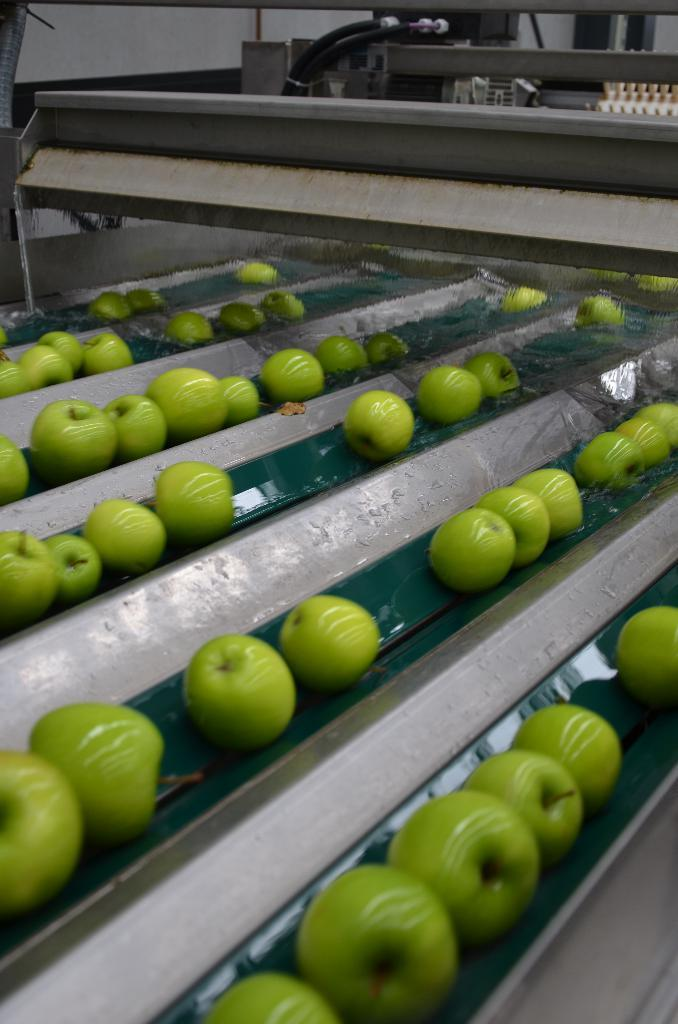What color are the fruits in the image? The fruits in the image are green. What are the fruits placed on? The fruits are on metal objects. What can be seen in the background of the image? There are machines visible in the background of the image. What type of rod can be seen holding the pickles in the image? There are no pickles or rods present in the image; it features green color fruits on metal objects. What type of print is visible on the fruits in the image? There is no print visible on the fruits in the image; they are simply green color fruits. 